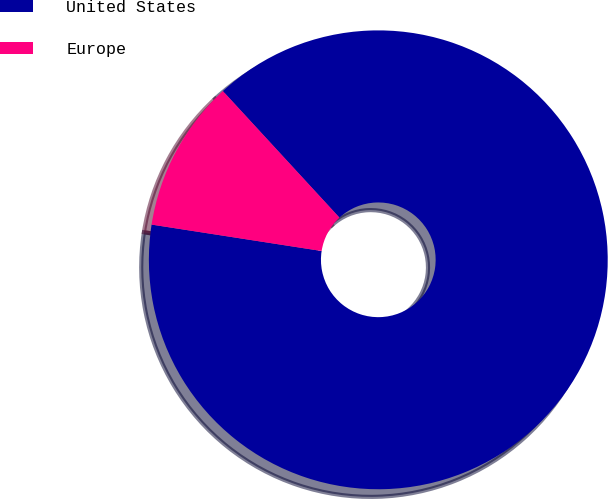Convert chart to OTSL. <chart><loc_0><loc_0><loc_500><loc_500><pie_chart><fcel>United States<fcel>Europe<nl><fcel>89.3%<fcel>10.7%<nl></chart> 